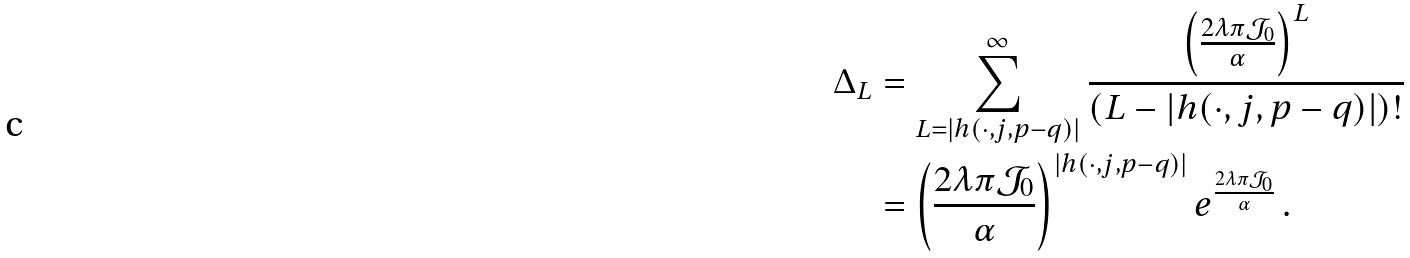<formula> <loc_0><loc_0><loc_500><loc_500>\Delta _ { L } & = \sum _ { L = | h ( \cdot , j , p - q ) | } ^ { \infty } \frac { \left ( \frac { 2 \lambda \pi \mathcal { J } _ { 0 } } { \alpha } \right ) ^ { L } } { ( L - | h ( \cdot , j , p - q ) | ) ! } \\ & = \left ( \frac { 2 \lambda \pi \mathcal { J } _ { 0 } } { \alpha } \right ) ^ { | h ( \cdot , j , p - q ) | } e ^ { \frac { 2 \lambda \pi \mathcal { J } _ { 0 } } { \alpha } } \, .</formula> 